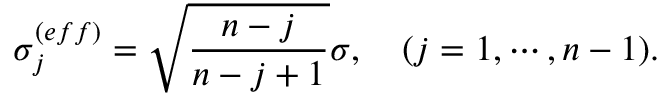<formula> <loc_0><loc_0><loc_500><loc_500>\sigma _ { j } ^ { ( e f f ) } = \sqrt { \frac { n - j } { n - j + 1 } } \sigma , ( j = 1 , \cdots , n - 1 ) .</formula> 